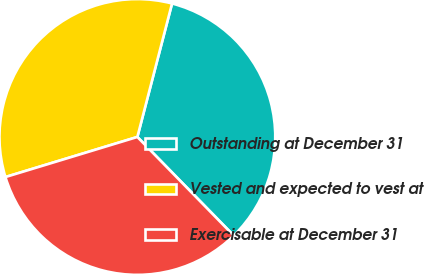Convert chart to OTSL. <chart><loc_0><loc_0><loc_500><loc_500><pie_chart><fcel>Outstanding at December 31<fcel>Vested and expected to vest at<fcel>Exercisable at December 31<nl><fcel>33.64%<fcel>33.74%<fcel>32.62%<nl></chart> 